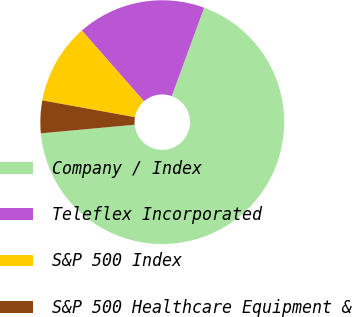Convert chart. <chart><loc_0><loc_0><loc_500><loc_500><pie_chart><fcel>Company / Index<fcel>Teleflex Incorporated<fcel>S&P 500 Index<fcel>S&P 500 Healthcare Equipment &<nl><fcel>67.95%<fcel>17.05%<fcel>10.68%<fcel>4.32%<nl></chart> 